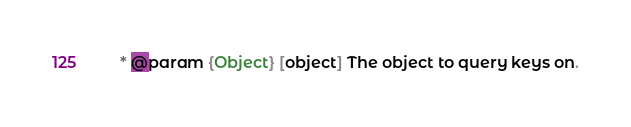<code> <loc_0><loc_0><loc_500><loc_500><_JavaScript_> * @param {Object} [object] The object to query keys on.</code> 